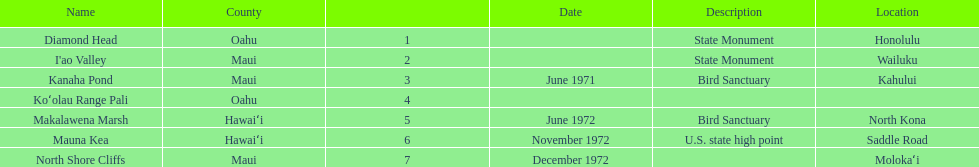Is kanaha pond a state monument or a bird sanctuary? Bird Sanctuary. 